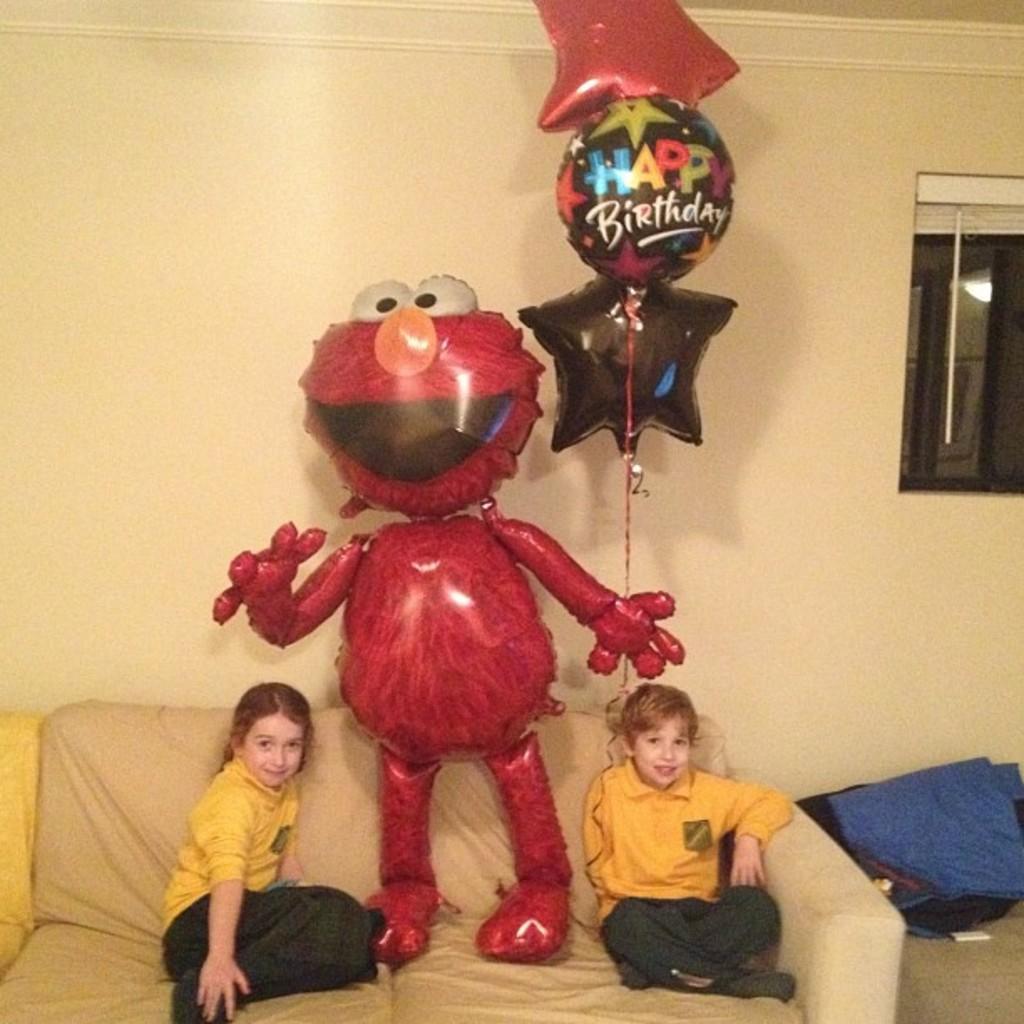In one or two sentences, can you explain what this image depicts? In this image there are two kids sitting on the couch, in between them there is an inflatable doll, beside the couch there are some objects, behind the couch there is a window on the wall. 